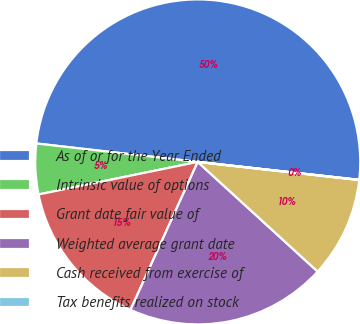<chart> <loc_0><loc_0><loc_500><loc_500><pie_chart><fcel>As of or for the Year Ended<fcel>Intrinsic value of options<fcel>Grant date fair value of<fcel>Weighted average grant date<fcel>Cash received from exercise of<fcel>Tax benefits realized on stock<nl><fcel>49.95%<fcel>5.02%<fcel>15.0%<fcel>20.0%<fcel>10.01%<fcel>0.02%<nl></chart> 